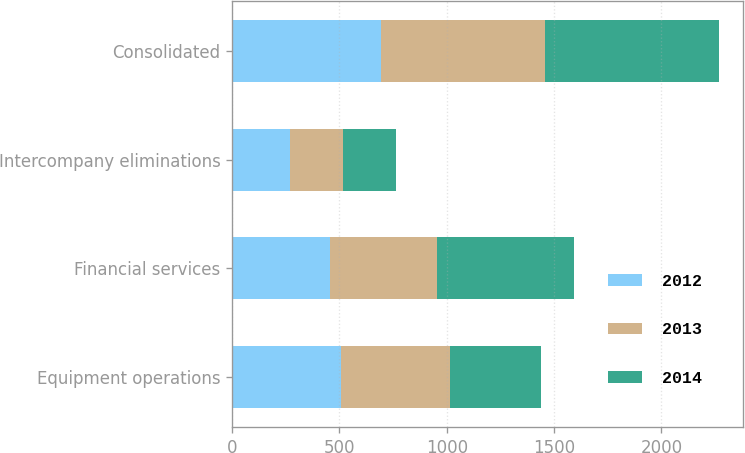Convert chart to OTSL. <chart><loc_0><loc_0><loc_500><loc_500><stacked_bar_chart><ecel><fcel>Equipment operations<fcel>Financial services<fcel>Intercompany eliminations<fcel>Consolidated<nl><fcel>2012<fcel>506<fcel>454<fcel>268<fcel>692<nl><fcel>2013<fcel>511<fcel>502<fcel>247<fcel>766<nl><fcel>2014<fcel>420<fcel>638<fcel>248<fcel>810<nl></chart> 